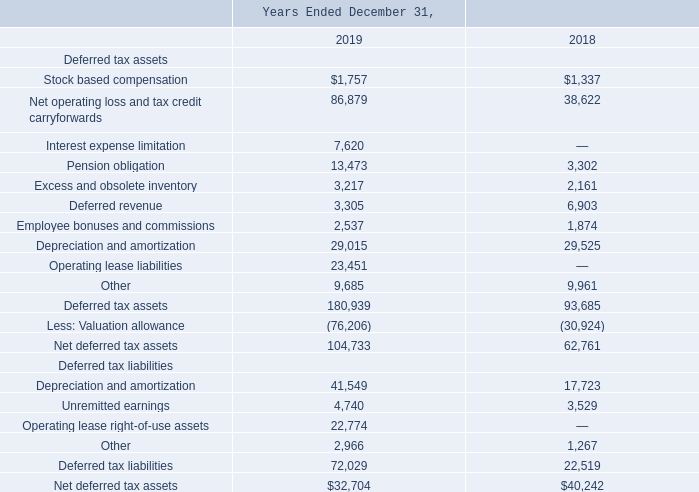ADVANCED ENERGY INDUSTRIES, INC. NOTES TO CONSOLIDATED FINANCIAL STATEMENTS – (continued) (in thousands, except per share amounts)
Deferred tax assets and liabilities are recognized for the future tax consequences of differences between the carrying amounts of assets and liabilities and their respective tax bases using enacted tax rates in effect for the year in which the differences are expected to be reversed. Significant deferred tax assets and liabilities consist of the following:
Of the $32.7 million and $40.2 million net deferred tax asset at December 31, 2019 and 2018, respectively, $42.7 million and $47.1 million is reflected as a net non-current deferred tax asset and $10.0 million and $7.0 million is reflected as a long-term liability at December 31, 2019 and 2018, respectively.
As of December 31, 2019, the Company has recorded a valuation allowance on $16.0 million of its U.S. domestic deferred tax assets, largely attributable to acquired federal capital loss carryforwards for which the Company does not have sufficient income in the character to realize that attribute, and state carryforward attributes that are expected to expire before sufficient income can be realized in those jurisdictions. The remaining valuation allowance on deferred tax assets approximates $60.2 million and is associated primarily with operations in Austria, Germany, Hong Kong and Switzerland. As of December 31, 2019, there is not sufficient positive evidence to conclude that such deferred tax assets, presently reduced by a valuation allowance, will be recognized. The December 31, 2019 valuation allowance balance reflects an increase of $45.3 million during the year. The change in the valuation allowance is primarily due to increases from acquired Artesyn positions and current year activity, partially offset by decreases due to foreign exchange movements
How much was reflected as a long-term liability in 2018?
Answer scale should be: million. $7.0 million. What was the stock based compensation in 2019?
Answer scale should be: thousand. $1,757. What was the Net operating loss and tax credit carryforwards in 2018?
Answer scale should be: thousand. 38,622. What was the change in pension obligation between 2018 and 2019?
Answer scale should be: thousand. 13,473-3,302
Answer: 10171. What was the change in Excess and obsolete inventory between 2018 and 2019?
Answer scale should be: thousand. 3,217-2,161
Answer: 1056. What was the percentage change in Net deferred tax assets between 2018 and 2019?
Answer scale should be: percent. ($32,704-$40,242)/$40,242
Answer: -18.73. 